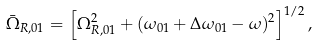<formula> <loc_0><loc_0><loc_500><loc_500>\bar { \Omega } _ { R , 0 1 } = \left [ \Omega _ { R , 0 1 } ^ { 2 } + ( \omega _ { 0 1 } + \Delta \omega _ { 0 1 } - \omega ) ^ { 2 } \right ] ^ { 1 / 2 } ,</formula> 